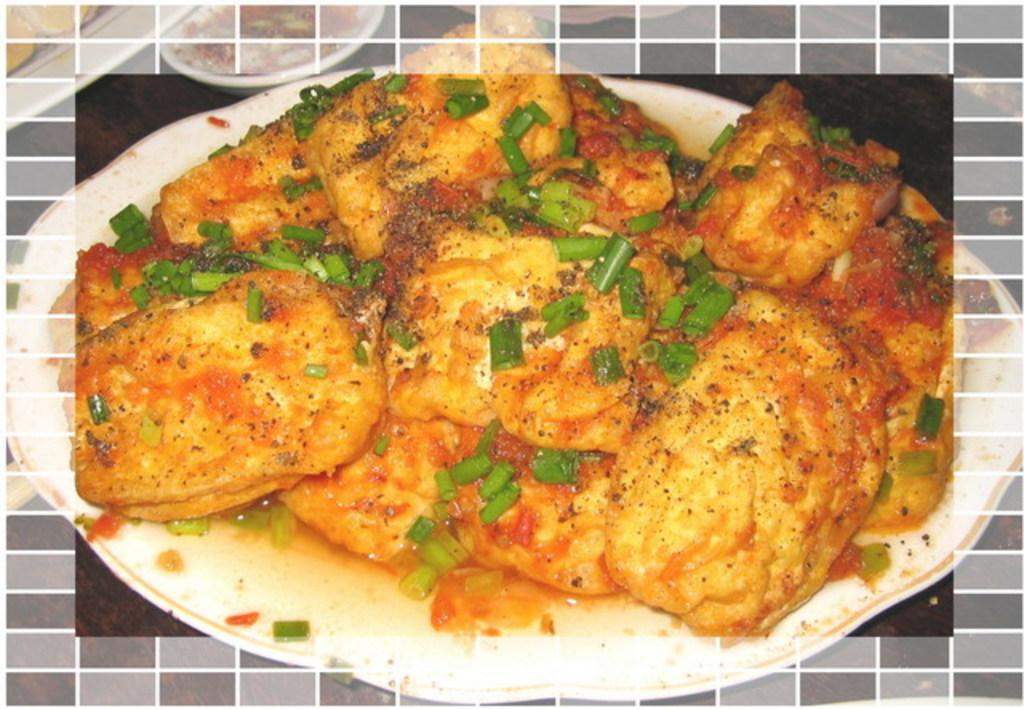What is on the plate that is visible in the image? There is food on a plate in the image. Where is the plate located in the image? The plate is placed on a table. What else can be seen on the table in the image? There are other bowls and plates on the table. What is there is a straw in the image? There is no straw present in the image. What level of difficulty is the riddle on the table in the image? There is no riddle present in the image. 